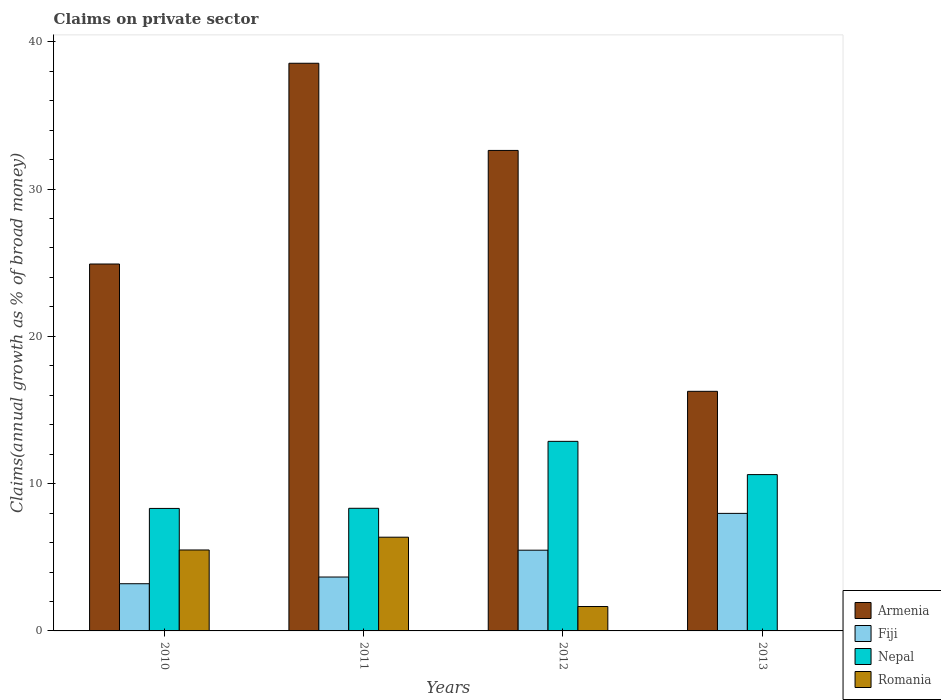How many different coloured bars are there?
Offer a terse response. 4. Are the number of bars per tick equal to the number of legend labels?
Provide a short and direct response. No. How many bars are there on the 4th tick from the right?
Ensure brevity in your answer.  4. What is the label of the 1st group of bars from the left?
Keep it short and to the point. 2010. In how many cases, is the number of bars for a given year not equal to the number of legend labels?
Make the answer very short. 1. What is the percentage of broad money claimed on private sector in Armenia in 2012?
Offer a terse response. 32.62. Across all years, what is the maximum percentage of broad money claimed on private sector in Romania?
Your answer should be very brief. 6.36. Across all years, what is the minimum percentage of broad money claimed on private sector in Armenia?
Offer a terse response. 16.27. What is the total percentage of broad money claimed on private sector in Fiji in the graph?
Provide a succinct answer. 20.32. What is the difference between the percentage of broad money claimed on private sector in Armenia in 2010 and that in 2013?
Provide a short and direct response. 8.64. What is the difference between the percentage of broad money claimed on private sector in Armenia in 2010 and the percentage of broad money claimed on private sector in Fiji in 2012?
Ensure brevity in your answer.  19.43. What is the average percentage of broad money claimed on private sector in Fiji per year?
Offer a terse response. 5.08. In the year 2010, what is the difference between the percentage of broad money claimed on private sector in Fiji and percentage of broad money claimed on private sector in Romania?
Offer a terse response. -2.29. In how many years, is the percentage of broad money claimed on private sector in Armenia greater than 16 %?
Your response must be concise. 4. What is the ratio of the percentage of broad money claimed on private sector in Fiji in 2011 to that in 2012?
Your response must be concise. 0.67. Is the percentage of broad money claimed on private sector in Fiji in 2010 less than that in 2011?
Keep it short and to the point. Yes. Is the difference between the percentage of broad money claimed on private sector in Fiji in 2010 and 2012 greater than the difference between the percentage of broad money claimed on private sector in Romania in 2010 and 2012?
Make the answer very short. No. What is the difference between the highest and the second highest percentage of broad money claimed on private sector in Fiji?
Provide a short and direct response. 2.5. What is the difference between the highest and the lowest percentage of broad money claimed on private sector in Romania?
Provide a succinct answer. 6.36. Is the sum of the percentage of broad money claimed on private sector in Fiji in 2011 and 2012 greater than the maximum percentage of broad money claimed on private sector in Romania across all years?
Give a very brief answer. Yes. Is it the case that in every year, the sum of the percentage of broad money claimed on private sector in Fiji and percentage of broad money claimed on private sector in Nepal is greater than the sum of percentage of broad money claimed on private sector in Romania and percentage of broad money claimed on private sector in Armenia?
Your response must be concise. Yes. How many bars are there?
Offer a terse response. 15. Are all the bars in the graph horizontal?
Provide a succinct answer. No. How many years are there in the graph?
Keep it short and to the point. 4. What is the difference between two consecutive major ticks on the Y-axis?
Keep it short and to the point. 10. How are the legend labels stacked?
Offer a very short reply. Vertical. What is the title of the graph?
Provide a succinct answer. Claims on private sector. What is the label or title of the X-axis?
Make the answer very short. Years. What is the label or title of the Y-axis?
Make the answer very short. Claims(annual growth as % of broad money). What is the Claims(annual growth as % of broad money) in Armenia in 2010?
Give a very brief answer. 24.91. What is the Claims(annual growth as % of broad money) in Fiji in 2010?
Your answer should be compact. 3.2. What is the Claims(annual growth as % of broad money) of Nepal in 2010?
Make the answer very short. 8.32. What is the Claims(annual growth as % of broad money) in Romania in 2010?
Provide a short and direct response. 5.49. What is the Claims(annual growth as % of broad money) of Armenia in 2011?
Provide a succinct answer. 38.54. What is the Claims(annual growth as % of broad money) in Fiji in 2011?
Keep it short and to the point. 3.66. What is the Claims(annual growth as % of broad money) of Nepal in 2011?
Ensure brevity in your answer.  8.33. What is the Claims(annual growth as % of broad money) of Romania in 2011?
Your answer should be compact. 6.36. What is the Claims(annual growth as % of broad money) in Armenia in 2012?
Ensure brevity in your answer.  32.62. What is the Claims(annual growth as % of broad money) of Fiji in 2012?
Offer a terse response. 5.48. What is the Claims(annual growth as % of broad money) of Nepal in 2012?
Ensure brevity in your answer.  12.87. What is the Claims(annual growth as % of broad money) in Romania in 2012?
Your answer should be compact. 1.66. What is the Claims(annual growth as % of broad money) in Armenia in 2013?
Offer a terse response. 16.27. What is the Claims(annual growth as % of broad money) of Fiji in 2013?
Keep it short and to the point. 7.98. What is the Claims(annual growth as % of broad money) of Nepal in 2013?
Offer a terse response. 10.61. Across all years, what is the maximum Claims(annual growth as % of broad money) in Armenia?
Make the answer very short. 38.54. Across all years, what is the maximum Claims(annual growth as % of broad money) of Fiji?
Keep it short and to the point. 7.98. Across all years, what is the maximum Claims(annual growth as % of broad money) of Nepal?
Give a very brief answer. 12.87. Across all years, what is the maximum Claims(annual growth as % of broad money) of Romania?
Provide a short and direct response. 6.36. Across all years, what is the minimum Claims(annual growth as % of broad money) in Armenia?
Offer a terse response. 16.27. Across all years, what is the minimum Claims(annual growth as % of broad money) of Fiji?
Provide a succinct answer. 3.2. Across all years, what is the minimum Claims(annual growth as % of broad money) in Nepal?
Keep it short and to the point. 8.32. What is the total Claims(annual growth as % of broad money) of Armenia in the graph?
Your answer should be compact. 112.34. What is the total Claims(annual growth as % of broad money) of Fiji in the graph?
Provide a short and direct response. 20.32. What is the total Claims(annual growth as % of broad money) in Nepal in the graph?
Provide a short and direct response. 40.12. What is the total Claims(annual growth as % of broad money) of Romania in the graph?
Your response must be concise. 13.51. What is the difference between the Claims(annual growth as % of broad money) of Armenia in 2010 and that in 2011?
Keep it short and to the point. -13.63. What is the difference between the Claims(annual growth as % of broad money) in Fiji in 2010 and that in 2011?
Your answer should be compact. -0.46. What is the difference between the Claims(annual growth as % of broad money) of Nepal in 2010 and that in 2011?
Keep it short and to the point. -0.01. What is the difference between the Claims(annual growth as % of broad money) of Romania in 2010 and that in 2011?
Provide a succinct answer. -0.87. What is the difference between the Claims(annual growth as % of broad money) of Armenia in 2010 and that in 2012?
Provide a succinct answer. -7.71. What is the difference between the Claims(annual growth as % of broad money) of Fiji in 2010 and that in 2012?
Ensure brevity in your answer.  -2.28. What is the difference between the Claims(annual growth as % of broad money) in Nepal in 2010 and that in 2012?
Your answer should be very brief. -4.55. What is the difference between the Claims(annual growth as % of broad money) of Romania in 2010 and that in 2012?
Make the answer very short. 3.84. What is the difference between the Claims(annual growth as % of broad money) in Armenia in 2010 and that in 2013?
Your response must be concise. 8.64. What is the difference between the Claims(annual growth as % of broad money) of Fiji in 2010 and that in 2013?
Give a very brief answer. -4.78. What is the difference between the Claims(annual growth as % of broad money) in Nepal in 2010 and that in 2013?
Give a very brief answer. -2.3. What is the difference between the Claims(annual growth as % of broad money) in Armenia in 2011 and that in 2012?
Make the answer very short. 5.92. What is the difference between the Claims(annual growth as % of broad money) in Fiji in 2011 and that in 2012?
Your answer should be compact. -1.82. What is the difference between the Claims(annual growth as % of broad money) in Nepal in 2011 and that in 2012?
Offer a very short reply. -4.54. What is the difference between the Claims(annual growth as % of broad money) of Romania in 2011 and that in 2012?
Provide a short and direct response. 4.71. What is the difference between the Claims(annual growth as % of broad money) of Armenia in 2011 and that in 2013?
Your answer should be very brief. 22.27. What is the difference between the Claims(annual growth as % of broad money) in Fiji in 2011 and that in 2013?
Ensure brevity in your answer.  -4.32. What is the difference between the Claims(annual growth as % of broad money) in Nepal in 2011 and that in 2013?
Provide a short and direct response. -2.29. What is the difference between the Claims(annual growth as % of broad money) of Armenia in 2012 and that in 2013?
Make the answer very short. 16.35. What is the difference between the Claims(annual growth as % of broad money) in Fiji in 2012 and that in 2013?
Offer a very short reply. -2.5. What is the difference between the Claims(annual growth as % of broad money) of Nepal in 2012 and that in 2013?
Make the answer very short. 2.26. What is the difference between the Claims(annual growth as % of broad money) of Armenia in 2010 and the Claims(annual growth as % of broad money) of Fiji in 2011?
Offer a very short reply. 21.25. What is the difference between the Claims(annual growth as % of broad money) of Armenia in 2010 and the Claims(annual growth as % of broad money) of Nepal in 2011?
Provide a succinct answer. 16.58. What is the difference between the Claims(annual growth as % of broad money) in Armenia in 2010 and the Claims(annual growth as % of broad money) in Romania in 2011?
Offer a terse response. 18.55. What is the difference between the Claims(annual growth as % of broad money) in Fiji in 2010 and the Claims(annual growth as % of broad money) in Nepal in 2011?
Make the answer very short. -5.12. What is the difference between the Claims(annual growth as % of broad money) of Fiji in 2010 and the Claims(annual growth as % of broad money) of Romania in 2011?
Your answer should be compact. -3.16. What is the difference between the Claims(annual growth as % of broad money) of Nepal in 2010 and the Claims(annual growth as % of broad money) of Romania in 2011?
Your answer should be very brief. 1.95. What is the difference between the Claims(annual growth as % of broad money) of Armenia in 2010 and the Claims(annual growth as % of broad money) of Fiji in 2012?
Your answer should be compact. 19.43. What is the difference between the Claims(annual growth as % of broad money) in Armenia in 2010 and the Claims(annual growth as % of broad money) in Nepal in 2012?
Offer a terse response. 12.04. What is the difference between the Claims(annual growth as % of broad money) of Armenia in 2010 and the Claims(annual growth as % of broad money) of Romania in 2012?
Keep it short and to the point. 23.25. What is the difference between the Claims(annual growth as % of broad money) of Fiji in 2010 and the Claims(annual growth as % of broad money) of Nepal in 2012?
Give a very brief answer. -9.67. What is the difference between the Claims(annual growth as % of broad money) of Fiji in 2010 and the Claims(annual growth as % of broad money) of Romania in 2012?
Give a very brief answer. 1.55. What is the difference between the Claims(annual growth as % of broad money) of Nepal in 2010 and the Claims(annual growth as % of broad money) of Romania in 2012?
Your answer should be compact. 6.66. What is the difference between the Claims(annual growth as % of broad money) in Armenia in 2010 and the Claims(annual growth as % of broad money) in Fiji in 2013?
Provide a succinct answer. 16.93. What is the difference between the Claims(annual growth as % of broad money) in Armenia in 2010 and the Claims(annual growth as % of broad money) in Nepal in 2013?
Your answer should be very brief. 14.3. What is the difference between the Claims(annual growth as % of broad money) in Fiji in 2010 and the Claims(annual growth as % of broad money) in Nepal in 2013?
Offer a very short reply. -7.41. What is the difference between the Claims(annual growth as % of broad money) in Armenia in 2011 and the Claims(annual growth as % of broad money) in Fiji in 2012?
Make the answer very short. 33.06. What is the difference between the Claims(annual growth as % of broad money) in Armenia in 2011 and the Claims(annual growth as % of broad money) in Nepal in 2012?
Your answer should be very brief. 25.67. What is the difference between the Claims(annual growth as % of broad money) of Armenia in 2011 and the Claims(annual growth as % of broad money) of Romania in 2012?
Your response must be concise. 36.88. What is the difference between the Claims(annual growth as % of broad money) in Fiji in 2011 and the Claims(annual growth as % of broad money) in Nepal in 2012?
Keep it short and to the point. -9.21. What is the difference between the Claims(annual growth as % of broad money) in Fiji in 2011 and the Claims(annual growth as % of broad money) in Romania in 2012?
Give a very brief answer. 2. What is the difference between the Claims(annual growth as % of broad money) of Nepal in 2011 and the Claims(annual growth as % of broad money) of Romania in 2012?
Keep it short and to the point. 6.67. What is the difference between the Claims(annual growth as % of broad money) of Armenia in 2011 and the Claims(annual growth as % of broad money) of Fiji in 2013?
Your response must be concise. 30.56. What is the difference between the Claims(annual growth as % of broad money) in Armenia in 2011 and the Claims(annual growth as % of broad money) in Nepal in 2013?
Your response must be concise. 27.93. What is the difference between the Claims(annual growth as % of broad money) in Fiji in 2011 and the Claims(annual growth as % of broad money) in Nepal in 2013?
Offer a terse response. -6.95. What is the difference between the Claims(annual growth as % of broad money) in Armenia in 2012 and the Claims(annual growth as % of broad money) in Fiji in 2013?
Make the answer very short. 24.64. What is the difference between the Claims(annual growth as % of broad money) in Armenia in 2012 and the Claims(annual growth as % of broad money) in Nepal in 2013?
Ensure brevity in your answer.  22.01. What is the difference between the Claims(annual growth as % of broad money) in Fiji in 2012 and the Claims(annual growth as % of broad money) in Nepal in 2013?
Offer a terse response. -5.13. What is the average Claims(annual growth as % of broad money) of Armenia per year?
Make the answer very short. 28.08. What is the average Claims(annual growth as % of broad money) of Fiji per year?
Ensure brevity in your answer.  5.08. What is the average Claims(annual growth as % of broad money) in Nepal per year?
Offer a terse response. 10.03. What is the average Claims(annual growth as % of broad money) of Romania per year?
Make the answer very short. 3.38. In the year 2010, what is the difference between the Claims(annual growth as % of broad money) in Armenia and Claims(annual growth as % of broad money) in Fiji?
Your answer should be compact. 21.71. In the year 2010, what is the difference between the Claims(annual growth as % of broad money) of Armenia and Claims(annual growth as % of broad money) of Nepal?
Your response must be concise. 16.59. In the year 2010, what is the difference between the Claims(annual growth as % of broad money) in Armenia and Claims(annual growth as % of broad money) in Romania?
Give a very brief answer. 19.41. In the year 2010, what is the difference between the Claims(annual growth as % of broad money) in Fiji and Claims(annual growth as % of broad money) in Nepal?
Offer a very short reply. -5.11. In the year 2010, what is the difference between the Claims(annual growth as % of broad money) of Fiji and Claims(annual growth as % of broad money) of Romania?
Offer a very short reply. -2.29. In the year 2010, what is the difference between the Claims(annual growth as % of broad money) of Nepal and Claims(annual growth as % of broad money) of Romania?
Your answer should be compact. 2.82. In the year 2011, what is the difference between the Claims(annual growth as % of broad money) in Armenia and Claims(annual growth as % of broad money) in Fiji?
Give a very brief answer. 34.88. In the year 2011, what is the difference between the Claims(annual growth as % of broad money) in Armenia and Claims(annual growth as % of broad money) in Nepal?
Make the answer very short. 30.21. In the year 2011, what is the difference between the Claims(annual growth as % of broad money) of Armenia and Claims(annual growth as % of broad money) of Romania?
Provide a short and direct response. 32.18. In the year 2011, what is the difference between the Claims(annual growth as % of broad money) of Fiji and Claims(annual growth as % of broad money) of Nepal?
Keep it short and to the point. -4.67. In the year 2011, what is the difference between the Claims(annual growth as % of broad money) of Fiji and Claims(annual growth as % of broad money) of Romania?
Offer a very short reply. -2.7. In the year 2011, what is the difference between the Claims(annual growth as % of broad money) of Nepal and Claims(annual growth as % of broad money) of Romania?
Provide a succinct answer. 1.96. In the year 2012, what is the difference between the Claims(annual growth as % of broad money) in Armenia and Claims(annual growth as % of broad money) in Fiji?
Your answer should be very brief. 27.14. In the year 2012, what is the difference between the Claims(annual growth as % of broad money) of Armenia and Claims(annual growth as % of broad money) of Nepal?
Make the answer very short. 19.75. In the year 2012, what is the difference between the Claims(annual growth as % of broad money) of Armenia and Claims(annual growth as % of broad money) of Romania?
Ensure brevity in your answer.  30.96. In the year 2012, what is the difference between the Claims(annual growth as % of broad money) of Fiji and Claims(annual growth as % of broad money) of Nepal?
Your response must be concise. -7.39. In the year 2012, what is the difference between the Claims(annual growth as % of broad money) in Fiji and Claims(annual growth as % of broad money) in Romania?
Your response must be concise. 3.82. In the year 2012, what is the difference between the Claims(annual growth as % of broad money) in Nepal and Claims(annual growth as % of broad money) in Romania?
Offer a terse response. 11.21. In the year 2013, what is the difference between the Claims(annual growth as % of broad money) of Armenia and Claims(annual growth as % of broad money) of Fiji?
Provide a short and direct response. 8.29. In the year 2013, what is the difference between the Claims(annual growth as % of broad money) in Armenia and Claims(annual growth as % of broad money) in Nepal?
Offer a very short reply. 5.65. In the year 2013, what is the difference between the Claims(annual growth as % of broad money) of Fiji and Claims(annual growth as % of broad money) of Nepal?
Provide a short and direct response. -2.63. What is the ratio of the Claims(annual growth as % of broad money) of Armenia in 2010 to that in 2011?
Your answer should be very brief. 0.65. What is the ratio of the Claims(annual growth as % of broad money) of Fiji in 2010 to that in 2011?
Offer a terse response. 0.88. What is the ratio of the Claims(annual growth as % of broad money) in Romania in 2010 to that in 2011?
Ensure brevity in your answer.  0.86. What is the ratio of the Claims(annual growth as % of broad money) of Armenia in 2010 to that in 2012?
Provide a succinct answer. 0.76. What is the ratio of the Claims(annual growth as % of broad money) in Fiji in 2010 to that in 2012?
Keep it short and to the point. 0.58. What is the ratio of the Claims(annual growth as % of broad money) in Nepal in 2010 to that in 2012?
Offer a terse response. 0.65. What is the ratio of the Claims(annual growth as % of broad money) in Romania in 2010 to that in 2012?
Provide a succinct answer. 3.32. What is the ratio of the Claims(annual growth as % of broad money) of Armenia in 2010 to that in 2013?
Provide a succinct answer. 1.53. What is the ratio of the Claims(annual growth as % of broad money) in Fiji in 2010 to that in 2013?
Your answer should be compact. 0.4. What is the ratio of the Claims(annual growth as % of broad money) of Nepal in 2010 to that in 2013?
Keep it short and to the point. 0.78. What is the ratio of the Claims(annual growth as % of broad money) of Armenia in 2011 to that in 2012?
Provide a succinct answer. 1.18. What is the ratio of the Claims(annual growth as % of broad money) in Fiji in 2011 to that in 2012?
Your answer should be compact. 0.67. What is the ratio of the Claims(annual growth as % of broad money) of Nepal in 2011 to that in 2012?
Your response must be concise. 0.65. What is the ratio of the Claims(annual growth as % of broad money) in Romania in 2011 to that in 2012?
Your answer should be compact. 3.84. What is the ratio of the Claims(annual growth as % of broad money) of Armenia in 2011 to that in 2013?
Provide a short and direct response. 2.37. What is the ratio of the Claims(annual growth as % of broad money) in Fiji in 2011 to that in 2013?
Offer a terse response. 0.46. What is the ratio of the Claims(annual growth as % of broad money) in Nepal in 2011 to that in 2013?
Make the answer very short. 0.78. What is the ratio of the Claims(annual growth as % of broad money) of Armenia in 2012 to that in 2013?
Your answer should be compact. 2.01. What is the ratio of the Claims(annual growth as % of broad money) in Fiji in 2012 to that in 2013?
Your answer should be very brief. 0.69. What is the ratio of the Claims(annual growth as % of broad money) in Nepal in 2012 to that in 2013?
Ensure brevity in your answer.  1.21. What is the difference between the highest and the second highest Claims(annual growth as % of broad money) in Armenia?
Your answer should be compact. 5.92. What is the difference between the highest and the second highest Claims(annual growth as % of broad money) in Fiji?
Provide a succinct answer. 2.5. What is the difference between the highest and the second highest Claims(annual growth as % of broad money) of Nepal?
Offer a very short reply. 2.26. What is the difference between the highest and the second highest Claims(annual growth as % of broad money) in Romania?
Your response must be concise. 0.87. What is the difference between the highest and the lowest Claims(annual growth as % of broad money) of Armenia?
Provide a succinct answer. 22.27. What is the difference between the highest and the lowest Claims(annual growth as % of broad money) in Fiji?
Your answer should be compact. 4.78. What is the difference between the highest and the lowest Claims(annual growth as % of broad money) in Nepal?
Provide a succinct answer. 4.55. What is the difference between the highest and the lowest Claims(annual growth as % of broad money) in Romania?
Offer a very short reply. 6.36. 